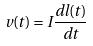Convert formula to latex. <formula><loc_0><loc_0><loc_500><loc_500>v ( t ) = I \frac { d l ( t ) } { d t }</formula> 